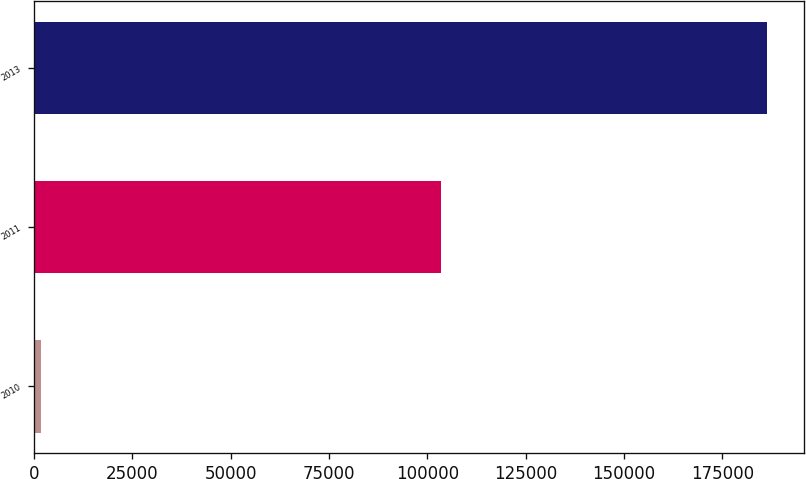<chart> <loc_0><loc_0><loc_500><loc_500><bar_chart><fcel>2010<fcel>2011<fcel>2013<nl><fcel>1673<fcel>103533<fcel>186460<nl></chart> 